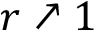<formula> <loc_0><loc_0><loc_500><loc_500>r \nearrow 1</formula> 